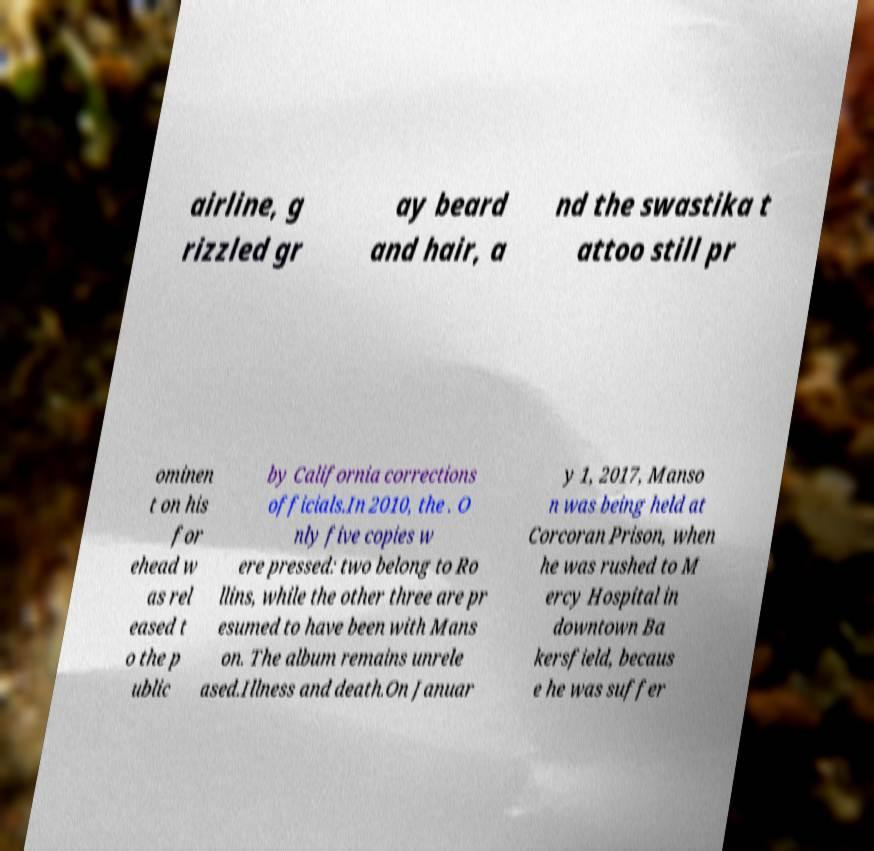Please read and relay the text visible in this image. What does it say? airline, g rizzled gr ay beard and hair, a nd the swastika t attoo still pr ominen t on his for ehead w as rel eased t o the p ublic by California corrections officials.In 2010, the . O nly five copies w ere pressed: two belong to Ro llins, while the other three are pr esumed to have been with Mans on. The album remains unrele ased.Illness and death.On Januar y 1, 2017, Manso n was being held at Corcoran Prison, when he was rushed to M ercy Hospital in downtown Ba kersfield, becaus e he was suffer 